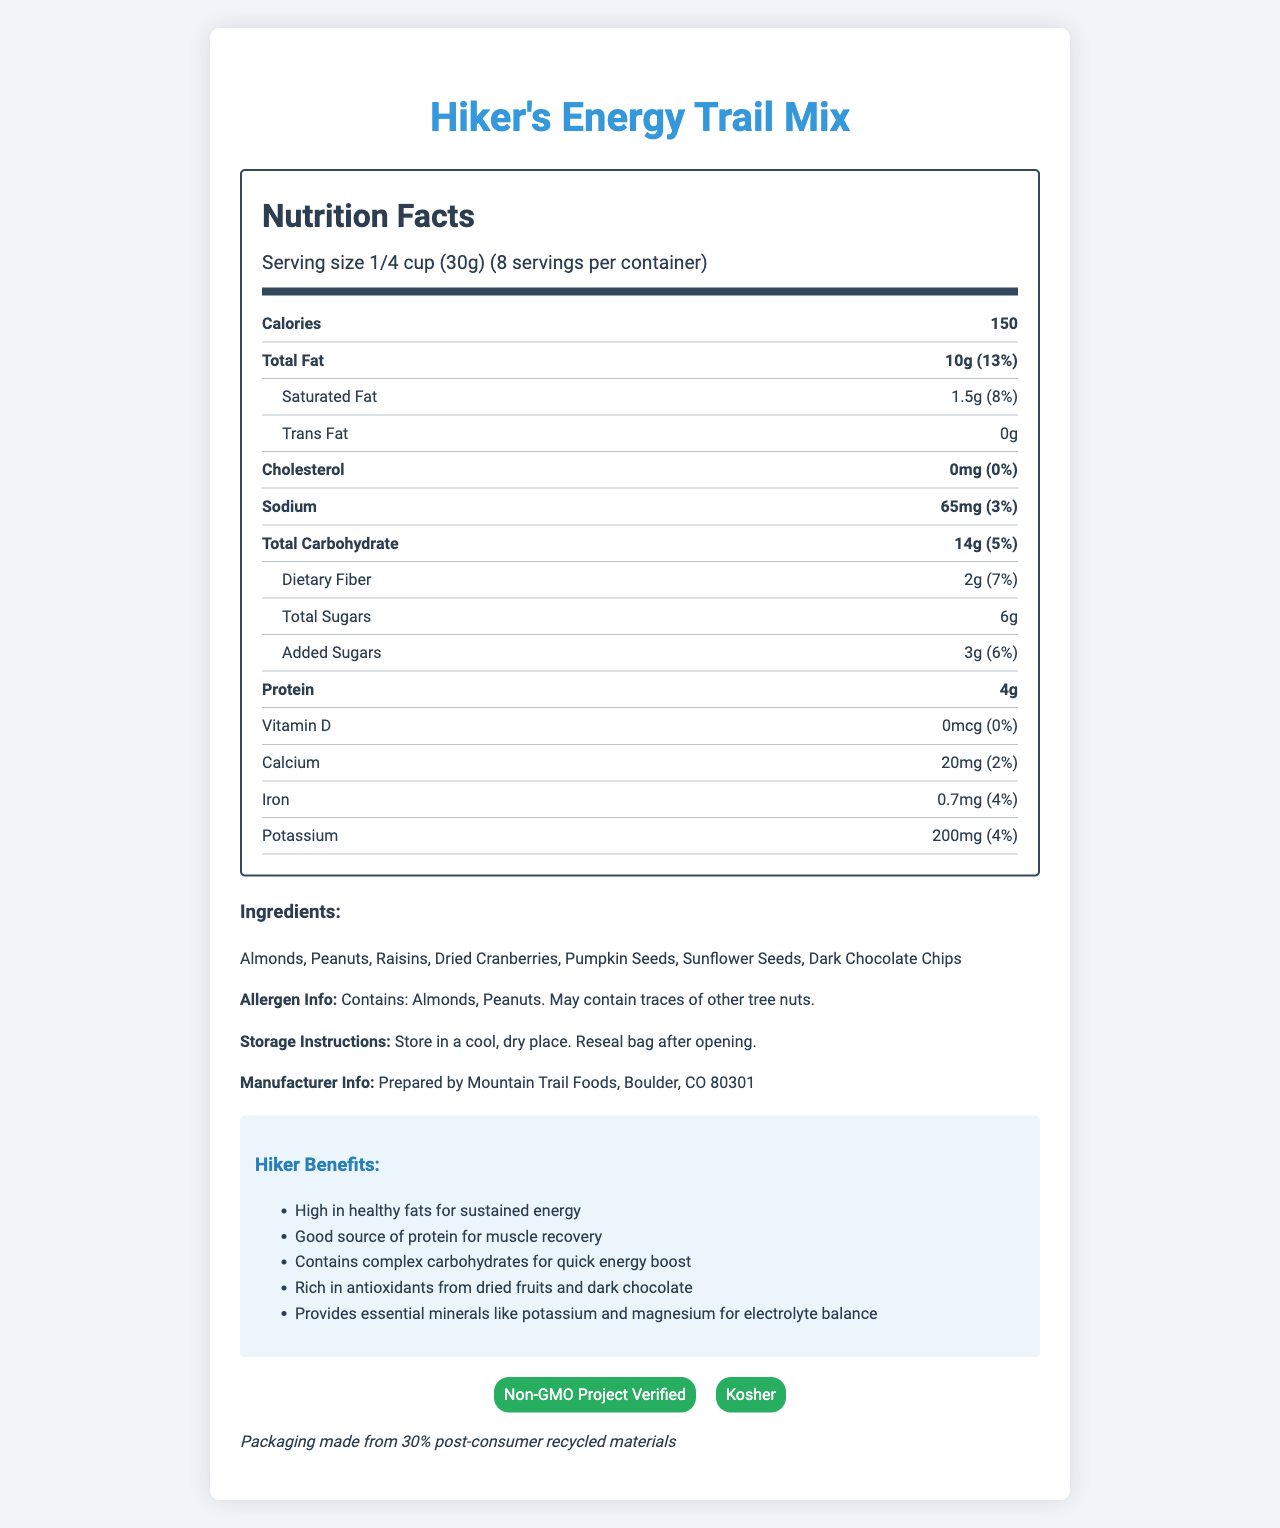what is the serving size? The serving size is clearly mentioned under the serving information section in the document as "1/4 cup (30g)".
Answer: 1/4 cup (30g) how many calories are in one serving? The calories per serving are listed as 150 in the document.
Answer: 150 what is the amount of total fat in one serving? The total amount of fat per serving is indicated as 10g in the nutrition facts section of the document.
Answer: 10g list three ingredients of the trail mix. The ingredients are listed in the ingredients section of the document; three examples are Almonds, Peanuts, and Raisins.
Answer: Almonds, Peanuts, Raisins how much sodium does one serving contain? The sodium content per serving is listed as 65mg in the nutrition facts.
Answer: 65mg what percentage of the daily value is the calcium content? The calcium content is listed as 20mg which is 2% of the daily value in the nutrition facts.
Answer: 2% which of the following certifications does the product have? 1. Organic 2. Non-GMO Project Verified 3. Gluten-Free 4. Halal The document lists "Non-GMO Project Verified" as one of its certifications.
Answer: 2 how many servings are there per container? A. 6 B. 8 C. 10 D. 12 The document mentions that there are 8 servings per container.
Answer: B what is the protein content per serving? A. 2g B. 3g C. 4g D. 5g The protein content per serving is listed as 4g.
Answer: C does the product contain any trans fat? The document clearly states that there is 0g of trans fat per serving.
Answer: No describe the main benefits of this trail mix for hikers. The "Hiker Benefits" section lists these benefits: high in healthy fats for sustained energy, good source of protein for muscle recovery, contains complex carbohydrates for quick energy boost, rich in antioxidants from dried fruits and dark chocolate, and provides essential minerals like potassium and magnesium for electrolyte balance.
Answer: High in healthy fats for sustained energy, good source of protein for muscle recovery, contains complex carbohydrates for quick energy boost, rich in antioxidants, provides essential minerals. what are the storage instructions for this product? The document provides the storage instructions under the storage instructions section.
Answer: Store in a cool, dry place. Reseal bag after opening. is this product kosher? The document lists Kosher as one of the certifications this trail mix has.
Answer: Yes Explain the nutritional information specifically about fats. The document lists the amounts and daily values for total fat, saturated fat, and trans fat in the nutrition facts section.
Answer: The trail mix contains a total of 10g of fat per serving, which is 13% of the daily value. It includes 1.5g of saturated fat (8% of the daily value) and 0g of trans fat. who is the manufacturer of this trail mix? The manufacturer info section of the document lists the manufacturer as Mountain Trail Foods, Boulder, CO 80301.
Answer: Mountain Trail Foods, Boulder, CO 80301 how much vitamin D is in one serving of the trail mix? The document lists the vitamin D content as 0mcg with 0% of the daily value.
Answer: 0mcg what kinds of nuts does the product contain? The ingredient list includes Almonds and Peanuts, which are types of nuts.
Answer: Almonds, Peanuts what is the source of added sugars in the document? The document does not specify the source of added sugars in the trail mix, merely listing their amount and daily value under "Total Sugars" and "Added Sugars".
Answer: Not enough information 